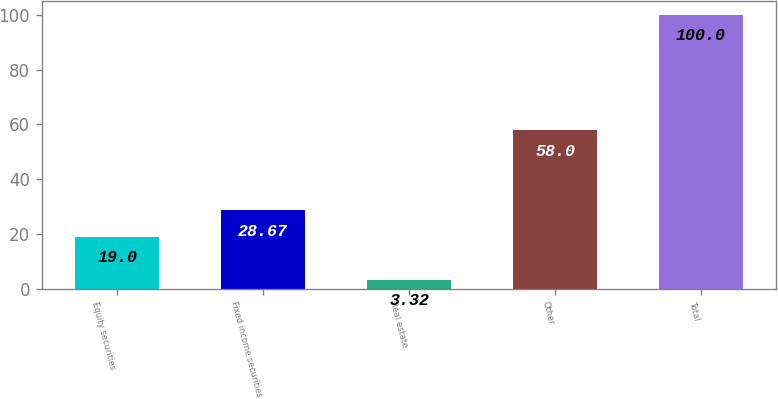Convert chart to OTSL. <chart><loc_0><loc_0><loc_500><loc_500><bar_chart><fcel>Equity securities<fcel>Fixed income securities<fcel>Real estate<fcel>Other<fcel>Total<nl><fcel>19<fcel>28.67<fcel>3.32<fcel>58<fcel>100<nl></chart> 